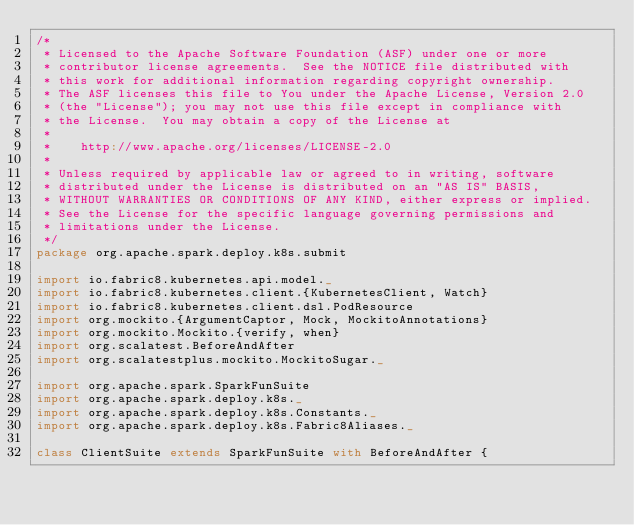<code> <loc_0><loc_0><loc_500><loc_500><_Scala_>/*
 * Licensed to the Apache Software Foundation (ASF) under one or more
 * contributor license agreements.  See the NOTICE file distributed with
 * this work for additional information regarding copyright ownership.
 * The ASF licenses this file to You under the Apache License, Version 2.0
 * (the "License"); you may not use this file except in compliance with
 * the License.  You may obtain a copy of the License at
 *
 *    http://www.apache.org/licenses/LICENSE-2.0
 *
 * Unless required by applicable law or agreed to in writing, software
 * distributed under the License is distributed on an "AS IS" BASIS,
 * WITHOUT WARRANTIES OR CONDITIONS OF ANY KIND, either express or implied.
 * See the License for the specific language governing permissions and
 * limitations under the License.
 */
package org.apache.spark.deploy.k8s.submit

import io.fabric8.kubernetes.api.model._
import io.fabric8.kubernetes.client.{KubernetesClient, Watch}
import io.fabric8.kubernetes.client.dsl.PodResource
import org.mockito.{ArgumentCaptor, Mock, MockitoAnnotations}
import org.mockito.Mockito.{verify, when}
import org.scalatest.BeforeAndAfter
import org.scalatestplus.mockito.MockitoSugar._

import org.apache.spark.SparkFunSuite
import org.apache.spark.deploy.k8s._
import org.apache.spark.deploy.k8s.Constants._
import org.apache.spark.deploy.k8s.Fabric8Aliases._

class ClientSuite extends SparkFunSuite with BeforeAndAfter {
</code> 